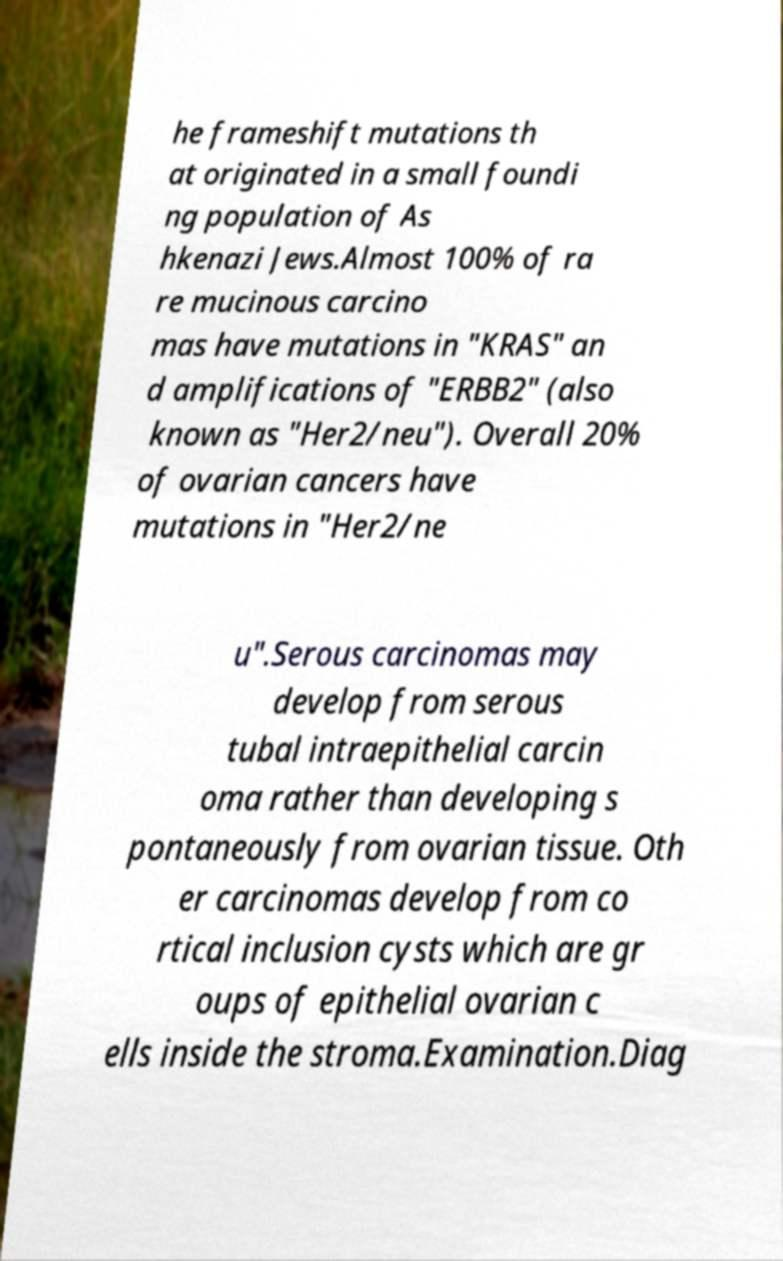Could you assist in decoding the text presented in this image and type it out clearly? he frameshift mutations th at originated in a small foundi ng population of As hkenazi Jews.Almost 100% of ra re mucinous carcino mas have mutations in "KRAS" an d amplifications of "ERBB2" (also known as "Her2/neu"). Overall 20% of ovarian cancers have mutations in "Her2/ne u".Serous carcinomas may develop from serous tubal intraepithelial carcin oma rather than developing s pontaneously from ovarian tissue. Oth er carcinomas develop from co rtical inclusion cysts which are gr oups of epithelial ovarian c ells inside the stroma.Examination.Diag 